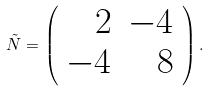<formula> <loc_0><loc_0><loc_500><loc_500>\tilde { N } = \left ( \begin{array} { r r } 2 & - 4 \\ - 4 & 8 \end{array} \right ) .</formula> 